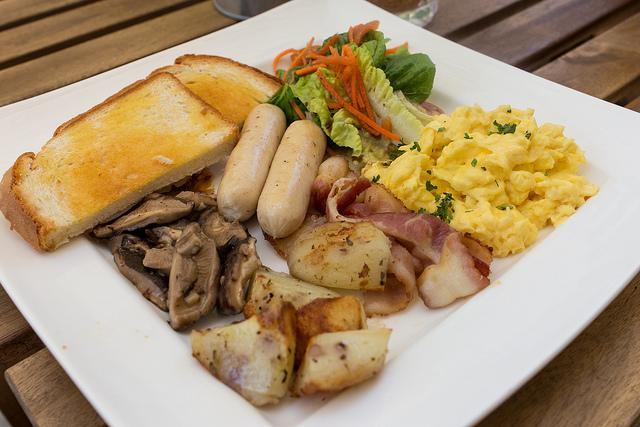What are the sausages sitting on?
Be succinct. Plate. Is this a ribeye steak?
Concise answer only. No. How many pieces of toast are there?
Give a very brief answer. 2. How are the eggs cooked?
Keep it brief. Scrambled. Where are the mushrooms?
Give a very brief answer. Plate. Do you need a fork to eat this?
Write a very short answer. Yes. What is mainly featured?
Concise answer only. Food. What is the hog dog sitting on?
Keep it brief. Plate. 